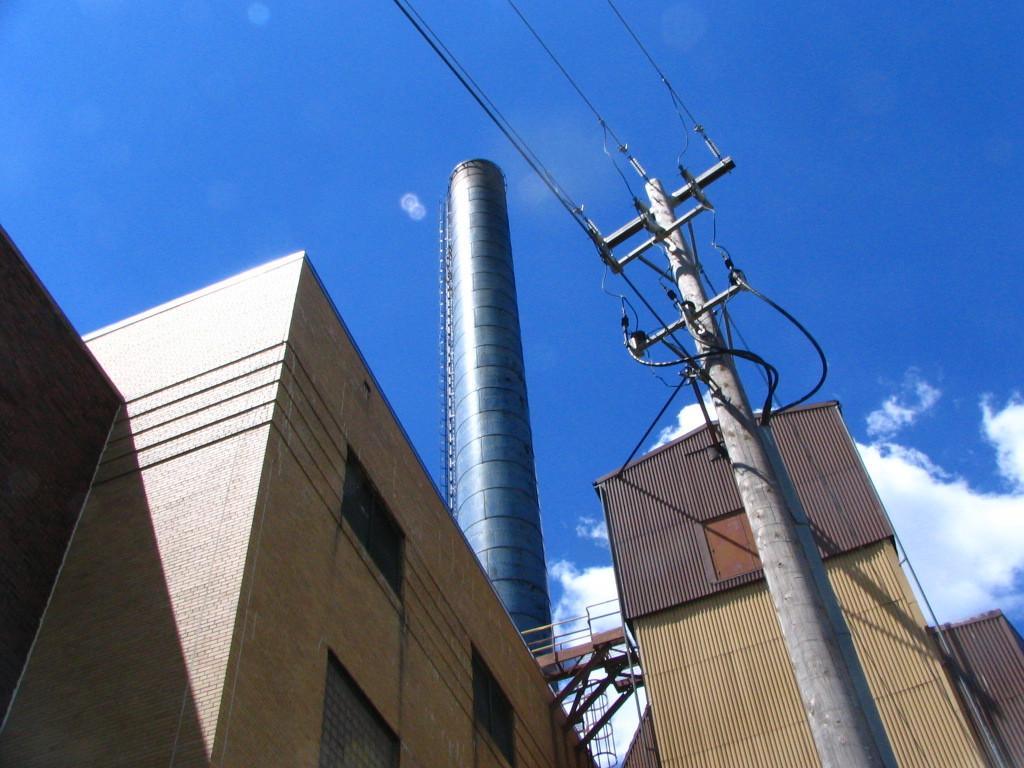Describe this image in one or two sentences. Here we can see buildings, pole, and lights. In the background there is sky with clouds. 